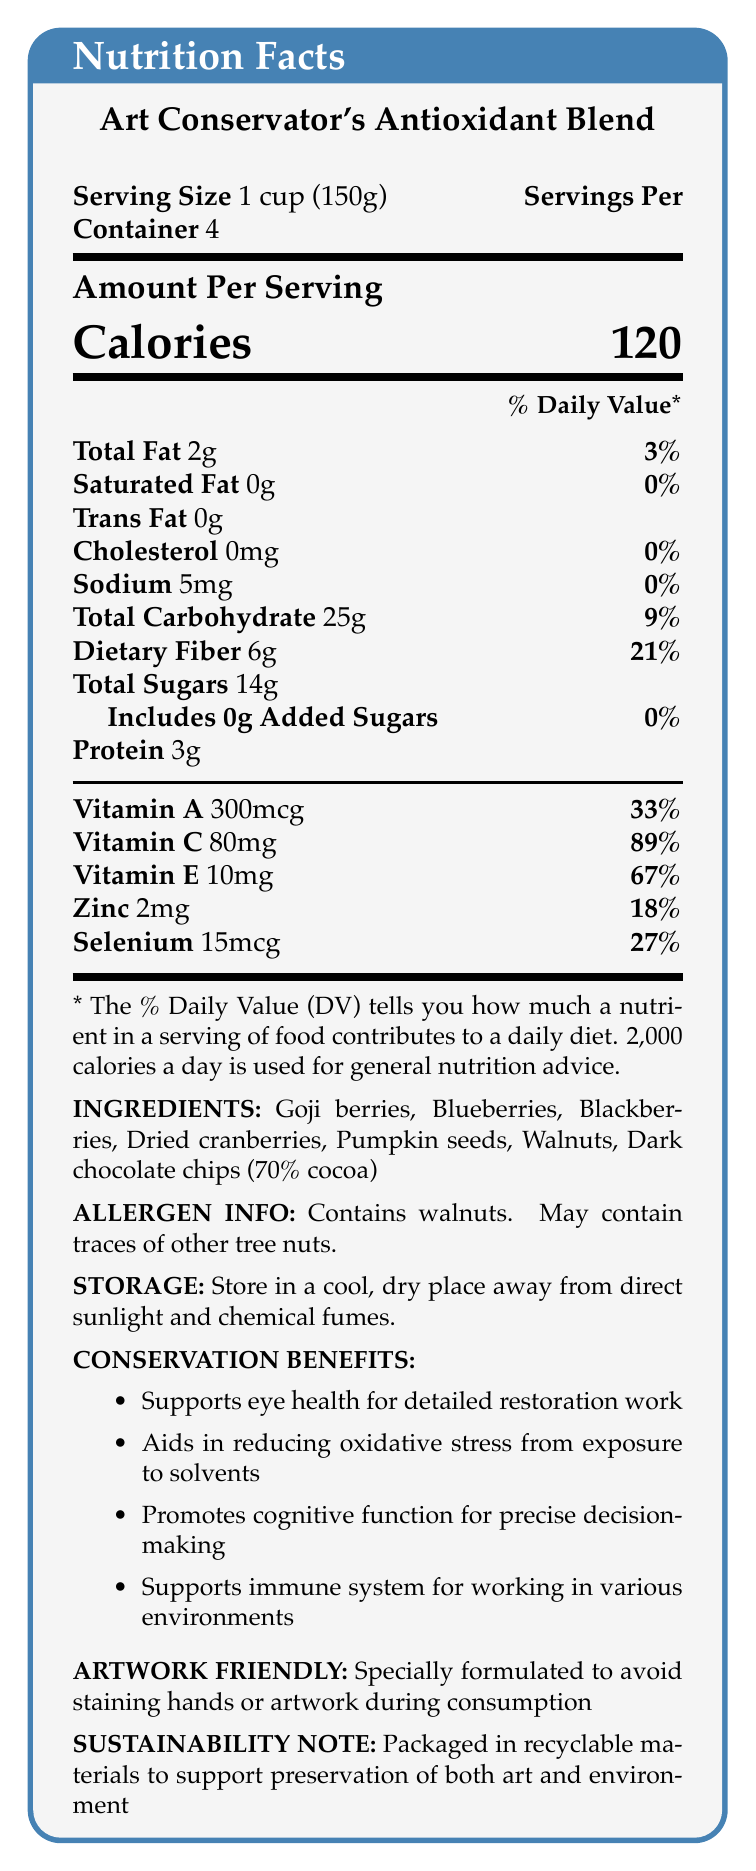what is the serving size? The document clearly states that the serving size is 1 cup (150g).
Answer: 1 cup (150g) how many servings are in one container? The serving size section mentions that there are 4 servings per container.
Answer: 4 what is the amount of Vitamin C per serving? Under the nutrition section, it indicates that each serving has 80mg of Vitamin C.
Answer: 80mg what allergen does this product contain? The allergen information clearly states that the product contains walnuts.
Answer: Walnuts how many calories are in one serving? The top section of the nutrition facts box mentions that there are 120 calories per serving.
Answer: 120 what is the daily value percentage of Vitamin E? The nutrition section lists Vitamin E with a daily value percentage of 67%.
Answer: 67% which ingredient is listed last in the ingredient list? Under the ingredients section, Dark chocolate chips (70% cocoa) are listed last.
Answer: Dark chocolate chips (70% cocoa) which vitamin has the highest daily value percentage? 
  A. Vitamin A
  B. Vitamin C
  C. Vitamin E
  D. Zinc Vitamin C has the highest daily value percentage at 89%.
Answer: B what is the total fat content per serving? 
  I. 0g
  II. 2g
  III. 6g
  IV. 25g The total fat content per serving is listed as 2g.
Answer: II does this product include any added sugars? The nutrition facts indicate that the product has 0g of added sugars.
Answer: No does the blend contain any protein? The nutrition facts list 3g of protein per serving, indicating the product does contain protein.
Answer: Yes summarize the main idea of this document. The document is a detailed nutrition facts label that highlights the health benefits and special considerations for art conservators, including nutritional content, serving information, and specific functional benefits.
Answer: The "Art Conservator's Antioxidant Blend" provides nutritional information for an antioxidant-rich food product recommended for art conservators. The label includes details on serving size, calories, fat content, various vitamins, and minerals, as well as ingredients and allergen information. The product is designed to support health benefits specific to the needs of art conservators, such as eye health, cognitive function, and immune support. It also emphasizes being artwork-friendly and environmentally sustainable. what is the sustainability note for this product? The bottom section of the label provides a sustainability note mentioning that the packaging is made of recyclable materials.
Answer: Packaged in recyclable materials to support the preservation of both art and the environment. how much sodium is in one serving? The nutrition facts state that there are 5mg of sodium per serving.
Answer: 5mg how should the product be stored? The storage instructions indicate this specific method for optimal storage.
Answer: Store in a cool, dry place away from direct sunlight and chemical fumes. which nutrient has the lowest daily value percentage? Sodium has the lowest daily value percentage at 0%.
Answer: Sodium what's the total carbohydrate content per serving? The total carbohydrate content per serving is stated as 25g in the nutrition facts section.
Answer: 25g how much dietary fiber is provided per serving? The nutrition section lists dietary fiber at 6g per serving.
Answer: 6g how would consuming this product benefit an art conservator's eye health? The document states that the product supports eye health for detailed restoration work among the conservation benefits listed.
Answer: Supports eye health for detailed restoration work how much Vitamin A does one serving contain? The nutrition facts mention that there is 300mcg of Vitamin A per serving.
Answer: 300mcg what type of fat is completely absent in this product? The nutrition facts list Trans fat content as 0g, indicating its complete absence.
Answer: Trans fat explain one of the conservation benefits of this product. One of the conservation benefits is that it supports the immune system, which helps individuals work in various environments. This is beneficial for art conservators who might have to deal with different physical conditions and potential exposure to various chemicals and materials.
Answer: Supports immune system for working in various environments can the source of the product's Vitamin E content be determined from the document? The document lists the amount of Vitamin E but does not specify its sources in the ingredient list or elsewhere.
Answer: Not enough information 